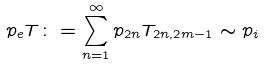<formula> <loc_0><loc_0><loc_500><loc_500>p _ { e } T \colon = \sum ^ { \infty } _ { n = 1 } p _ { 2 n } T _ { 2 n , 2 m - 1 } \sim p _ { i }</formula> 